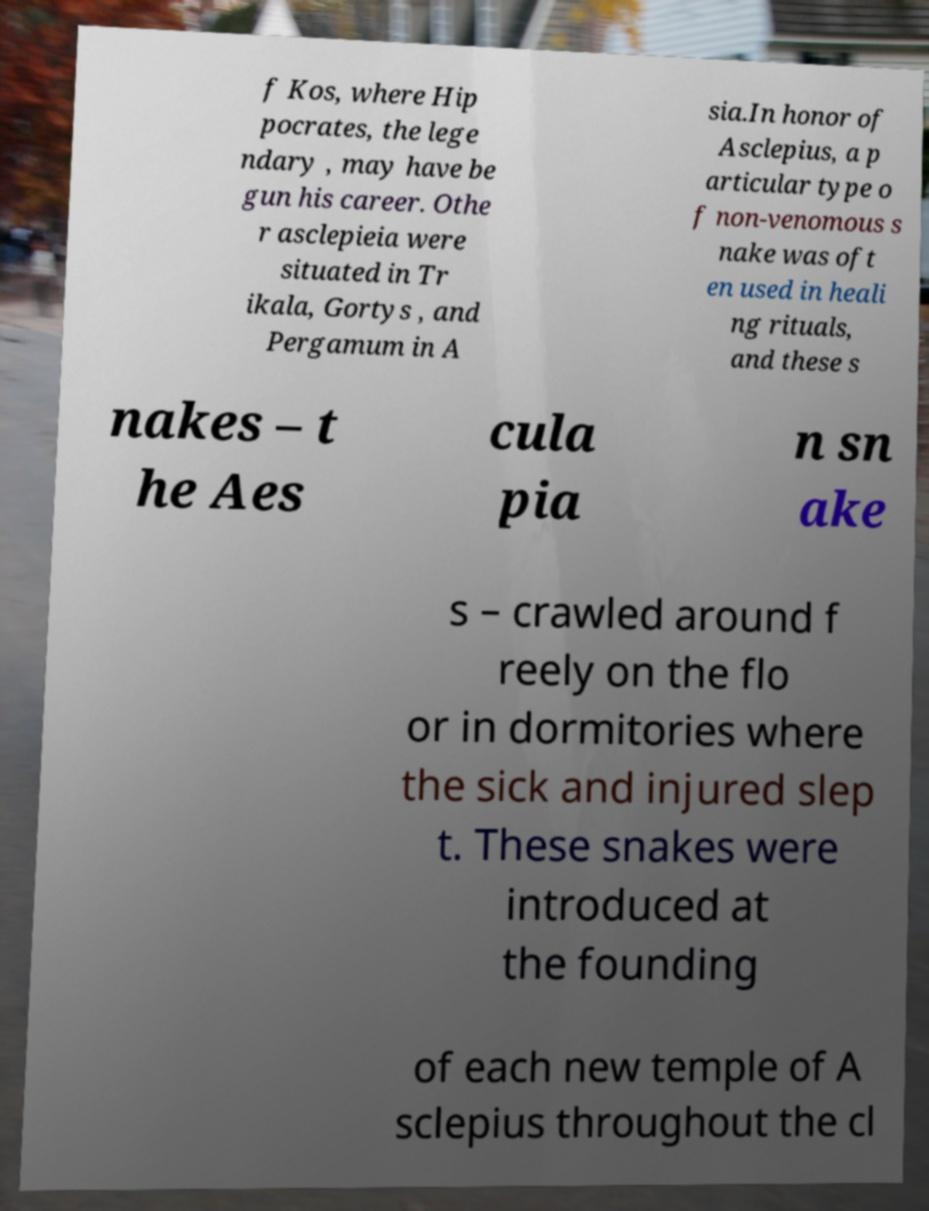Can you read and provide the text displayed in the image?This photo seems to have some interesting text. Can you extract and type it out for me? f Kos, where Hip pocrates, the lege ndary , may have be gun his career. Othe r asclepieia were situated in Tr ikala, Gortys , and Pergamum in A sia.In honor of Asclepius, a p articular type o f non-venomous s nake was oft en used in heali ng rituals, and these s nakes – t he Aes cula pia n sn ake s – crawled around f reely on the flo or in dormitories where the sick and injured slep t. These snakes were introduced at the founding of each new temple of A sclepius throughout the cl 